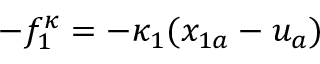<formula> <loc_0><loc_0><loc_500><loc_500>- f _ { 1 } ^ { \kappa } = - \kappa _ { 1 } ( x _ { 1 a } - u _ { a } )</formula> 